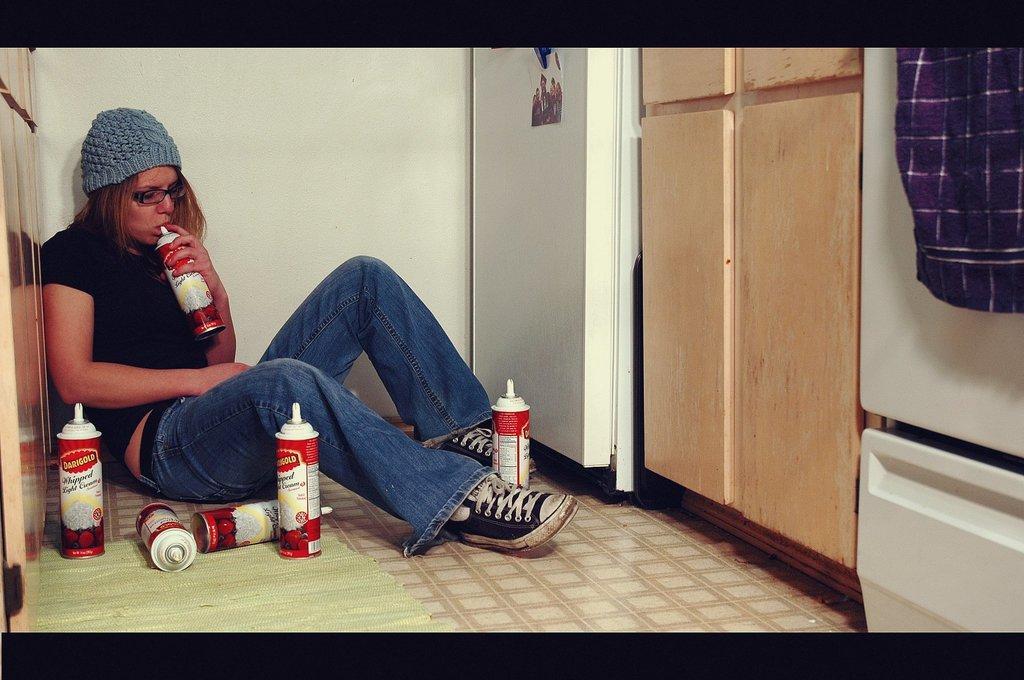Can you describe this image briefly? In this picture we can see bottles, photo, cloth, walls and a woman wore a cap, spectacle and sitting on the floor and some objects. 